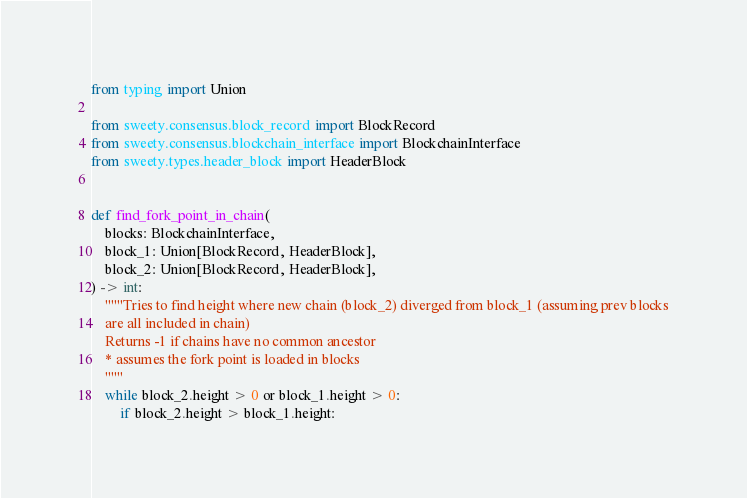<code> <loc_0><loc_0><loc_500><loc_500><_Python_>from typing import Union

from sweety.consensus.block_record import BlockRecord
from sweety.consensus.blockchain_interface import BlockchainInterface
from sweety.types.header_block import HeaderBlock


def find_fork_point_in_chain(
    blocks: BlockchainInterface,
    block_1: Union[BlockRecord, HeaderBlock],
    block_2: Union[BlockRecord, HeaderBlock],
) -> int:
    """Tries to find height where new chain (block_2) diverged from block_1 (assuming prev blocks
    are all included in chain)
    Returns -1 if chains have no common ancestor
    * assumes the fork point is loaded in blocks
    """
    while block_2.height > 0 or block_1.height > 0:
        if block_2.height > block_1.height:</code> 